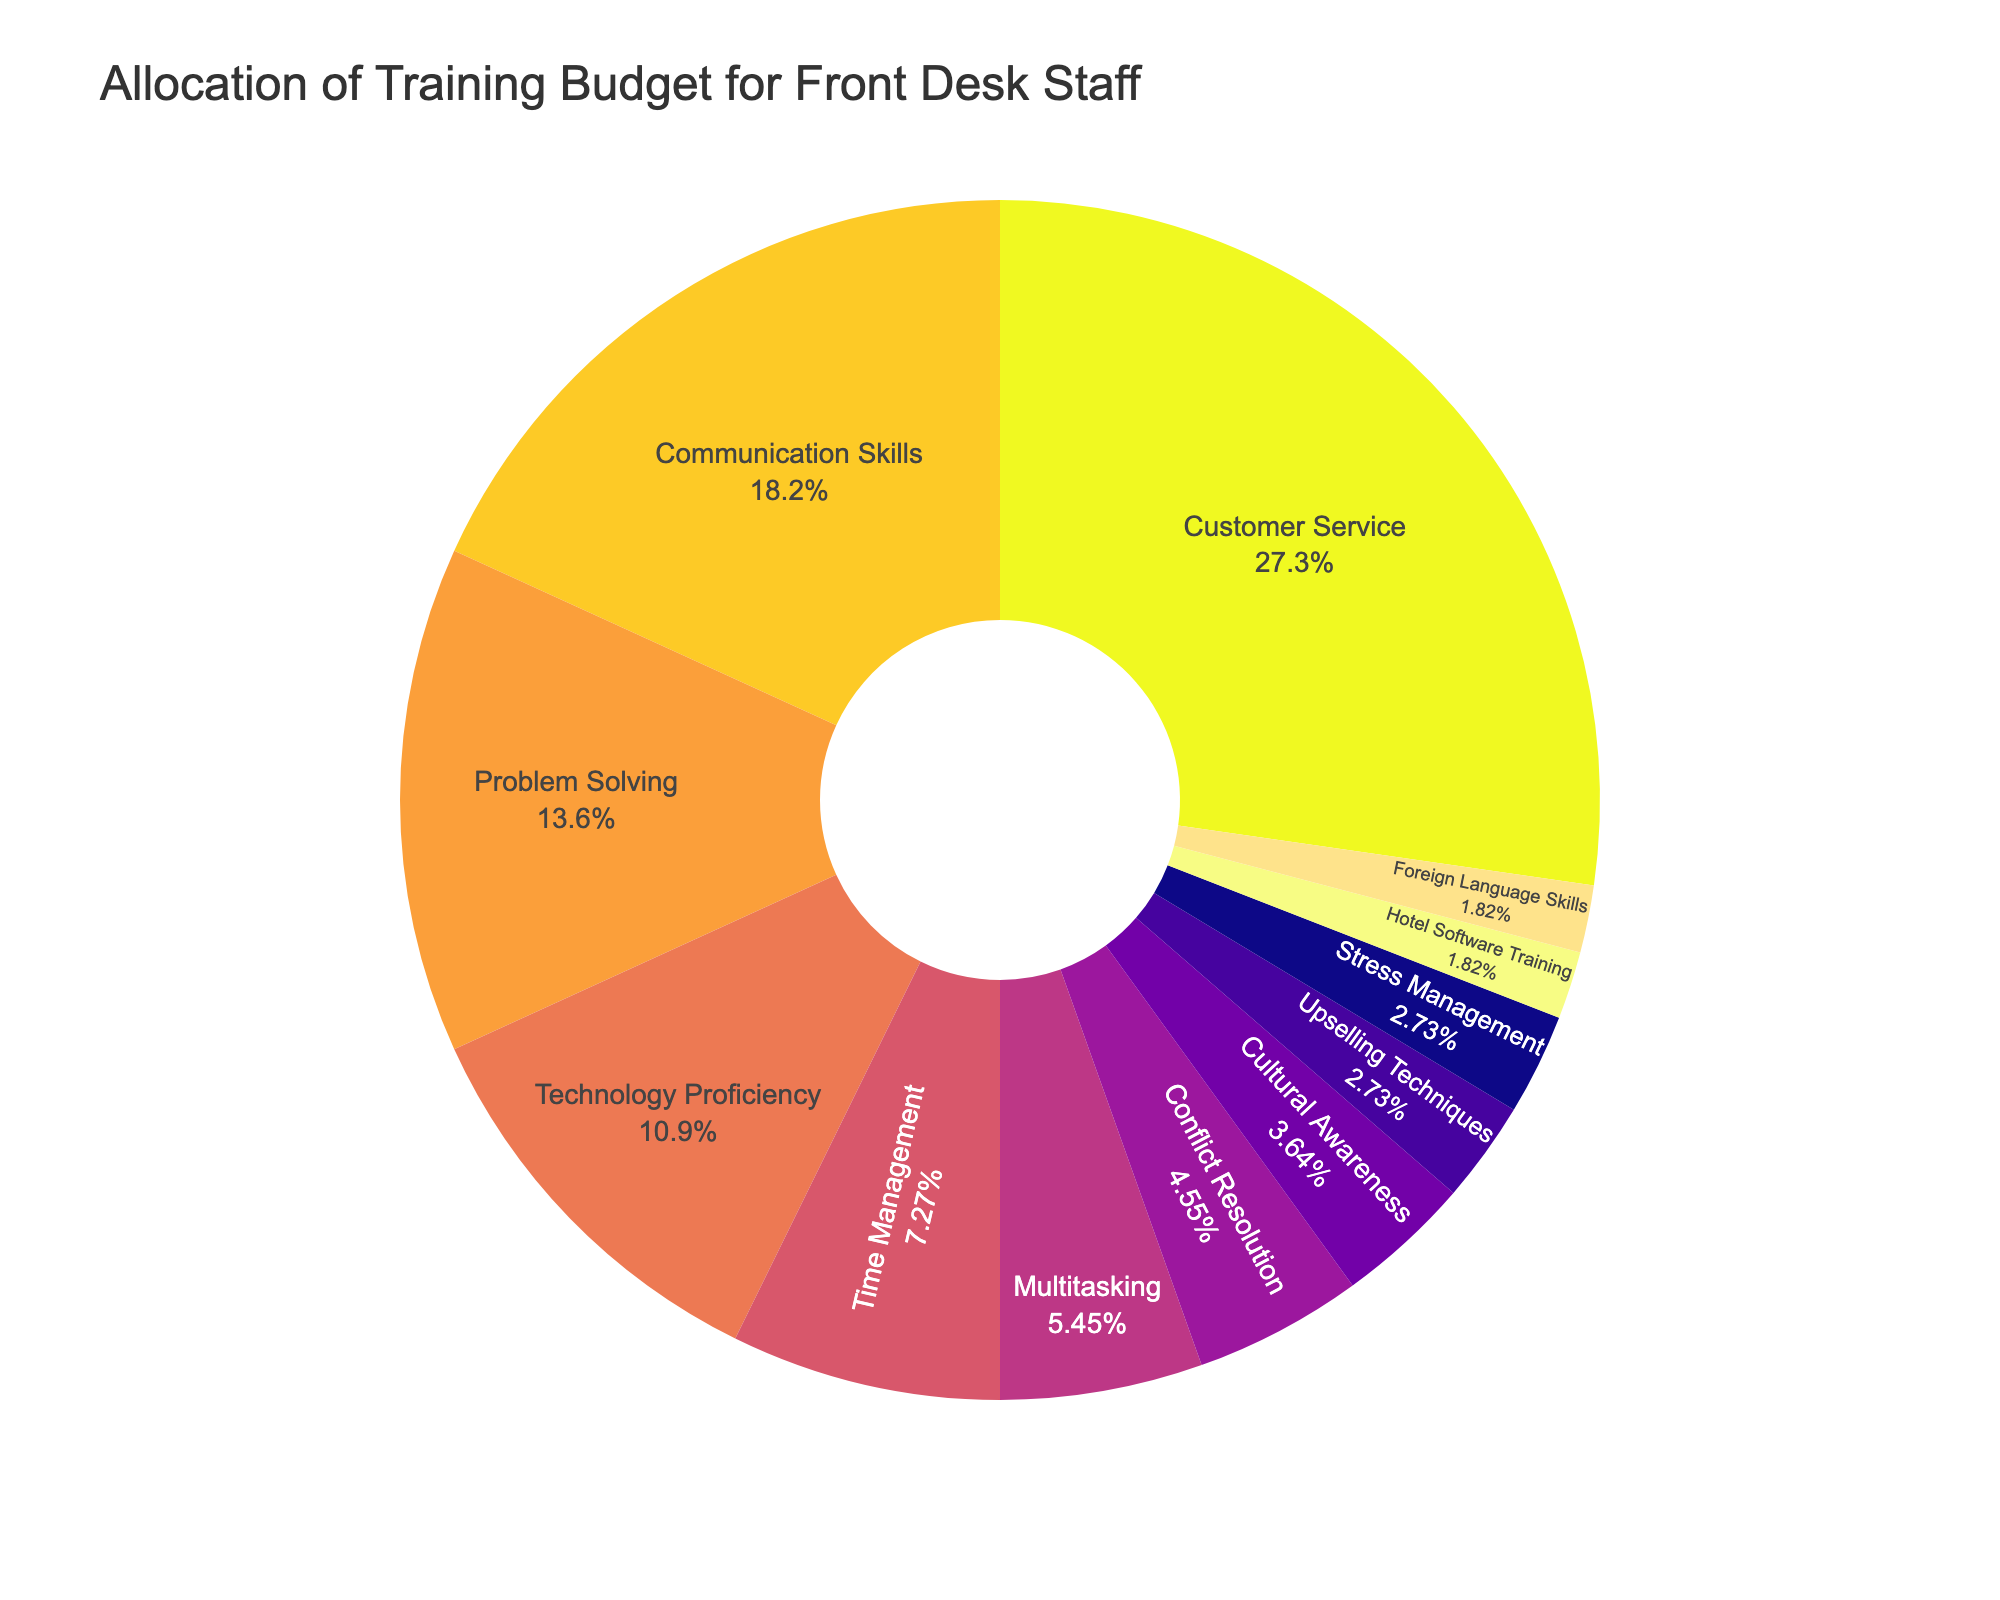What is the largest budget allocation for any skill area? By observing the pie chart, identify the slice with the largest percentage. "Customer Service" occupies the largest portion with a 30% allocation.
Answer: Customer Service Which skill area has the smallest budget allocation? Look for the smallest slice in the pie chart. "Hotel Software Training" and "Foreign Language Skills" seem to have the smallest portions with 2% each.
Answer: Hotel Software Training and Foreign Language Skills How much more budget is allocated to Customer Service compared to Conflict Resolution? Identify the percentages for both "Customer Service" (30%) and "Conflict Resolution" (5%). Calculate the difference: 30% - 5% = 25%.
Answer: 25% What is the combined budget allocation percentage for Technology Proficiency and Communication Skills? Find and add the percentages for "Technology Proficiency" (12%) and "Communication Skills" (20%). 12% + 20% = 32%.
Answer: 32% Which skill area has a higher budget allocation, Problem Solving or Time Management? Compare the percentages for "Problem Solving" (15%) and "Time Management" (8%). Problem Solving has a higher allocation.
Answer: Problem Solving Are any skill areas allocated exactly 3% of the training budget? Identify any slices labeled with 3%. Both "Upselling Techniques" and "Stress Management" slices are labeled with 3%.
Answer: Yes What is the average budget allocation percentage for all skill areas? Sum all the percentages (30 + 20 + 15 + 12 + 8 + 6 + 5 + 4 + 3 + 3 + 2 + 2 = 110%). The average would be this sum divided by the number of skill areas (11). 110% / 11 ≈ 10%.
Answer: 10% How does the budget allocation for Cultural Awareness compare to that for Foreign Language Skills? Compare the percentages for "Cultural Awareness" (4%) and "Foreign Language Skills" (2%). Cultural Awareness has a higher allocation.
Answer: Cultural Awareness is higher What is the total percentage of the training budget allocated to both Multitasking and Stress Management? Identify and sum the percentages for "Multitasking" (6%) and "Stress Management" (3%). 6% + 3% = 9%.
Answer: 9% Is there a larger budget allocation for Time Management or Conflict Resolution? Compare the percentages for "Time Management" (8%) and "Conflict Resolution" (5%). Time Management has a larger allocation.
Answer: Time Management 